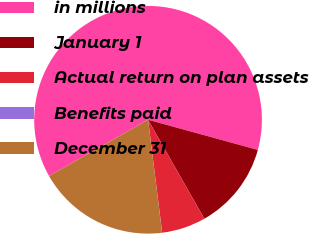Convert chart. <chart><loc_0><loc_0><loc_500><loc_500><pie_chart><fcel>in millions<fcel>January 1<fcel>Actual return on plan assets<fcel>Benefits paid<fcel>December 31<nl><fcel>62.49%<fcel>12.5%<fcel>6.25%<fcel>0.01%<fcel>18.75%<nl></chart> 